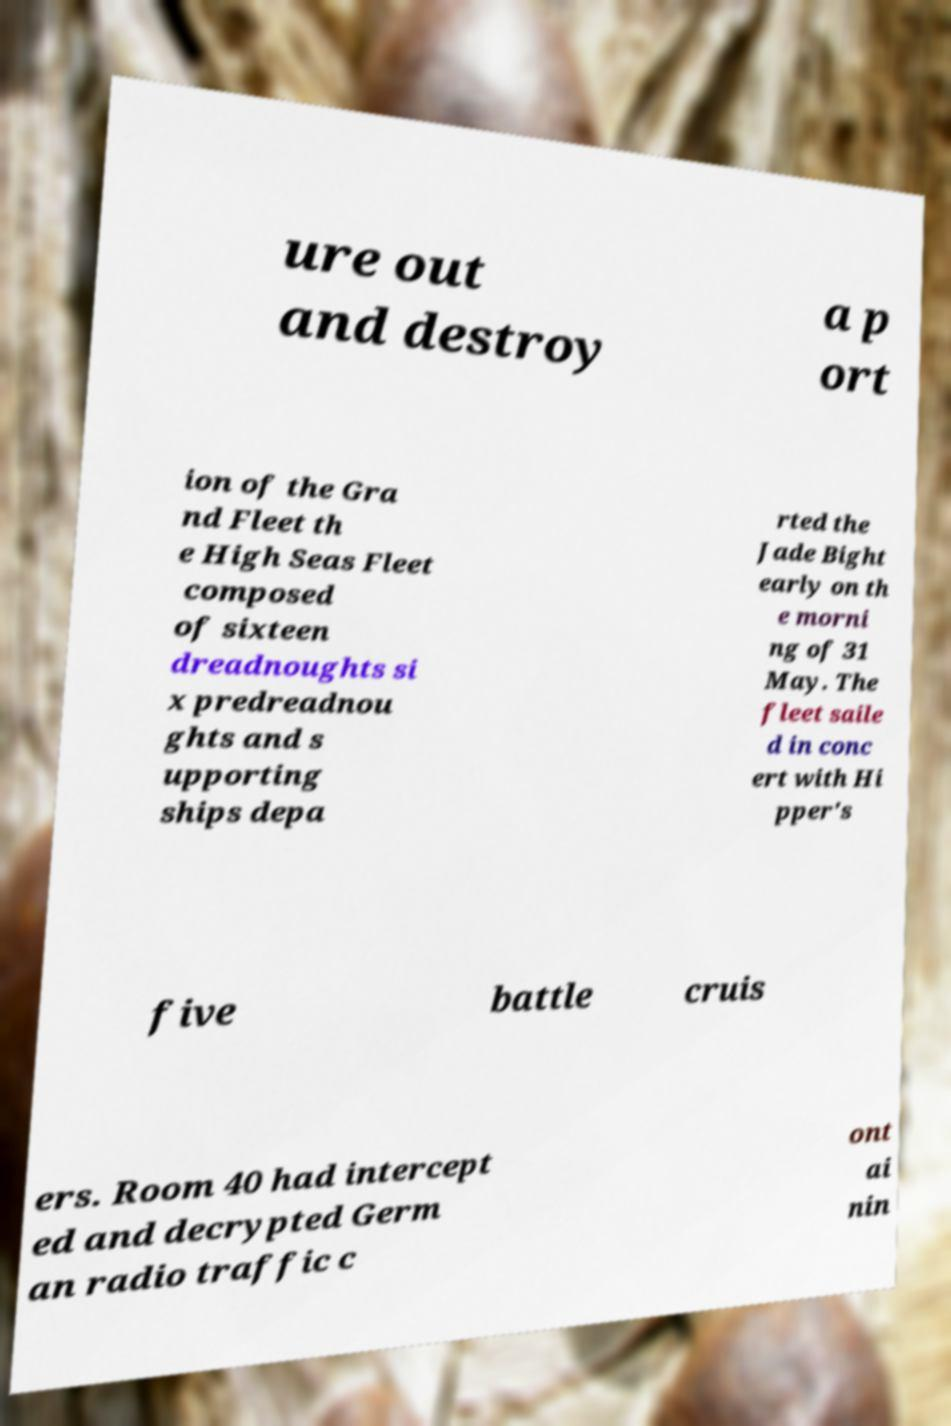Please identify and transcribe the text found in this image. ure out and destroy a p ort ion of the Gra nd Fleet th e High Seas Fleet composed of sixteen dreadnoughts si x predreadnou ghts and s upporting ships depa rted the Jade Bight early on th e morni ng of 31 May. The fleet saile d in conc ert with Hi pper's five battle cruis ers. Room 40 had intercept ed and decrypted Germ an radio traffic c ont ai nin 